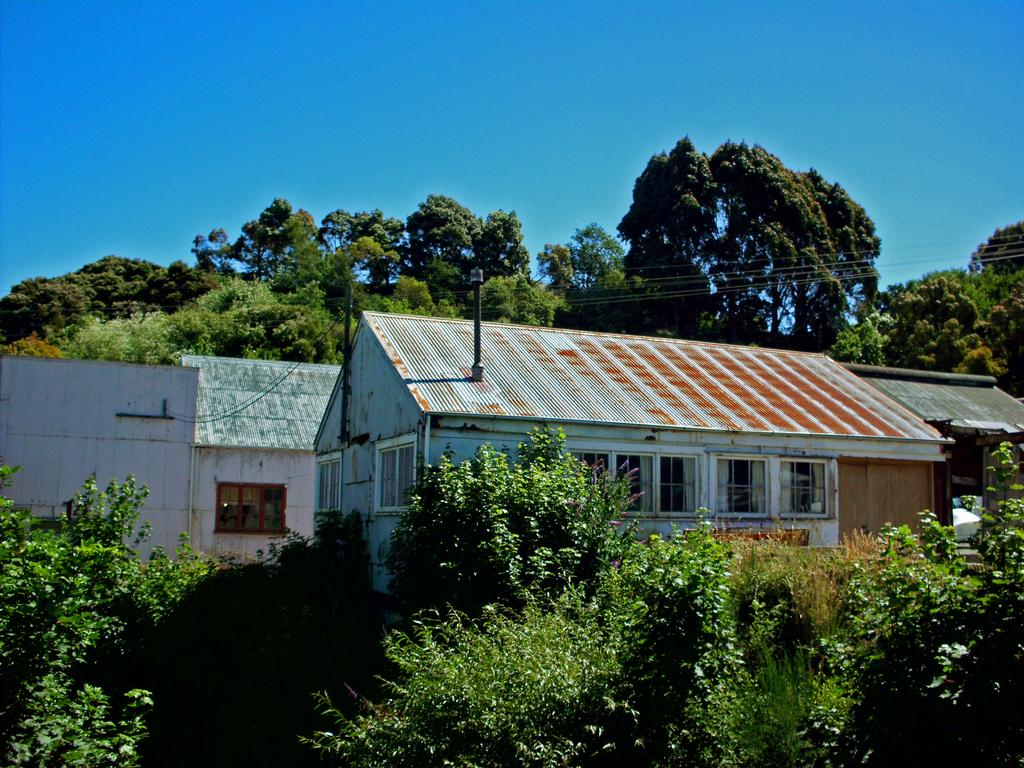What type of structures are visible in the image? There are houses in the image. the image. What is located in front of the houses? There are plants and bushes in front of the houses. What else can be seen at the top of the image? Trees are visible at the top of the image. What other objects are present in the image? Power line cables are present in the image. What is visible in the background of the image? The sky is visible in the image. Can you tell me who won the fight between the dad and the trees in the image? There is no fight or dad present in the image; it features houses, plants, bushes, trees, power line cables, and the sky. 